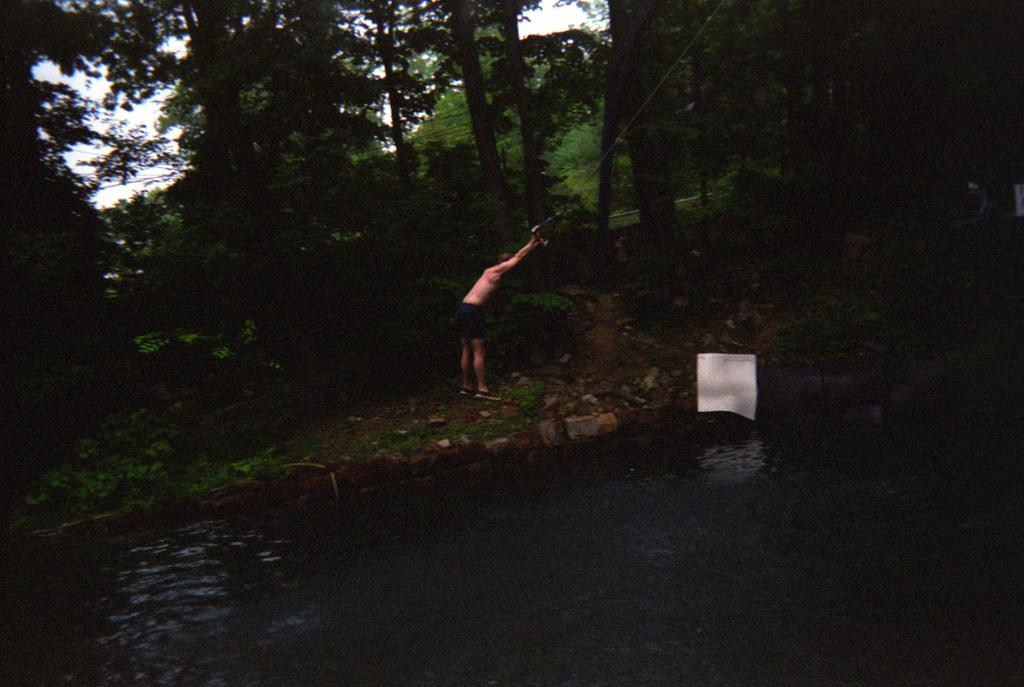What is the person doing at the bank of the lake? The person is standing at the bank of a lake and pulling a rope from the top. What can be seen in the background behind the person? There are trees visible behind the person. What type of heart-shaped object can be seen floating in the lake? There is no heart-shaped object visible in the image; it only features a person standing at the bank of a lake and pulling a rope from the top, with trees visible in the background. 